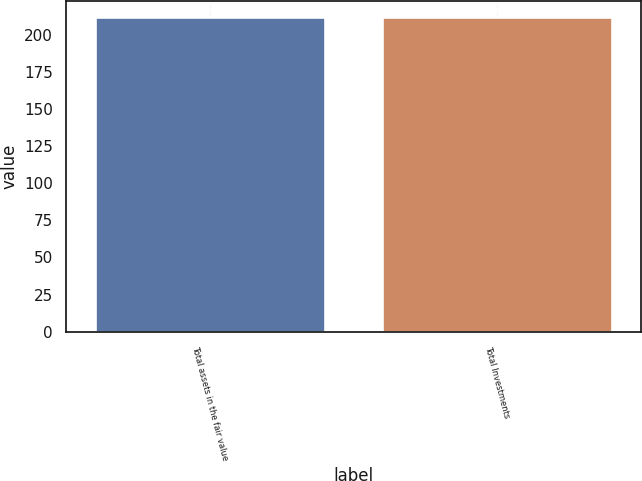<chart> <loc_0><loc_0><loc_500><loc_500><bar_chart><fcel>Total assets in the fair value<fcel>Total Investments<nl><fcel>212<fcel>212.1<nl></chart> 